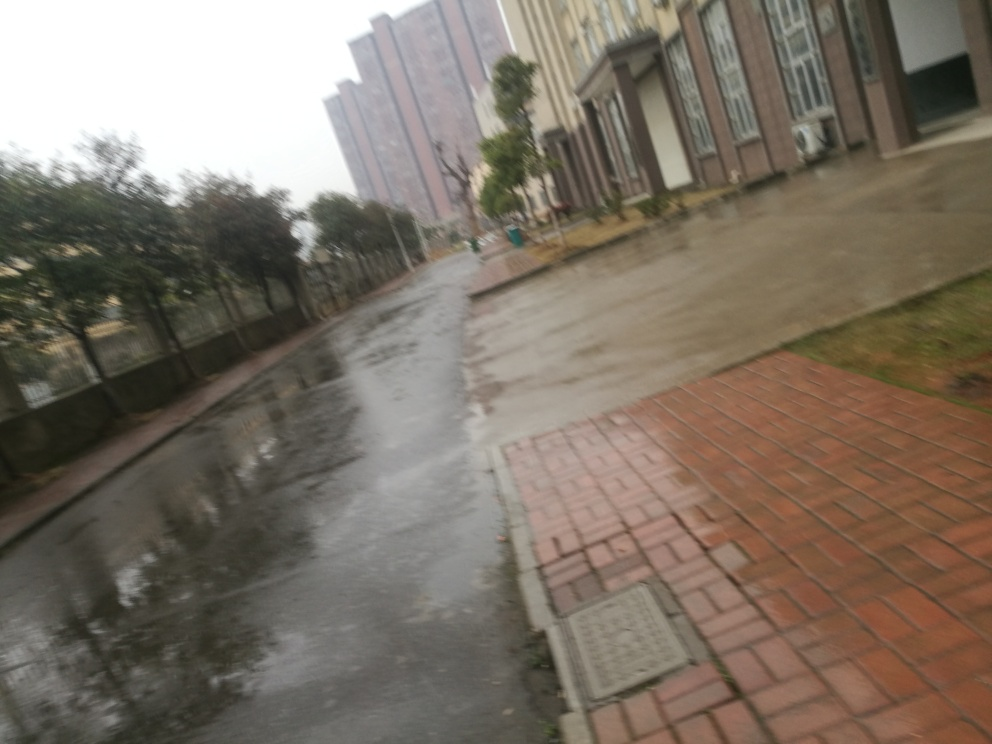Can you describe the setting of this image? The image depicts an outdoor urban environment on a rainy day. The ground is wet, likely from recent rain, and reflects the surrounding structures. There are tall residential buildings in the background, adding to the sense of a densely populated area. The red brick pathway and gated green areas give a sense of residential planning. 